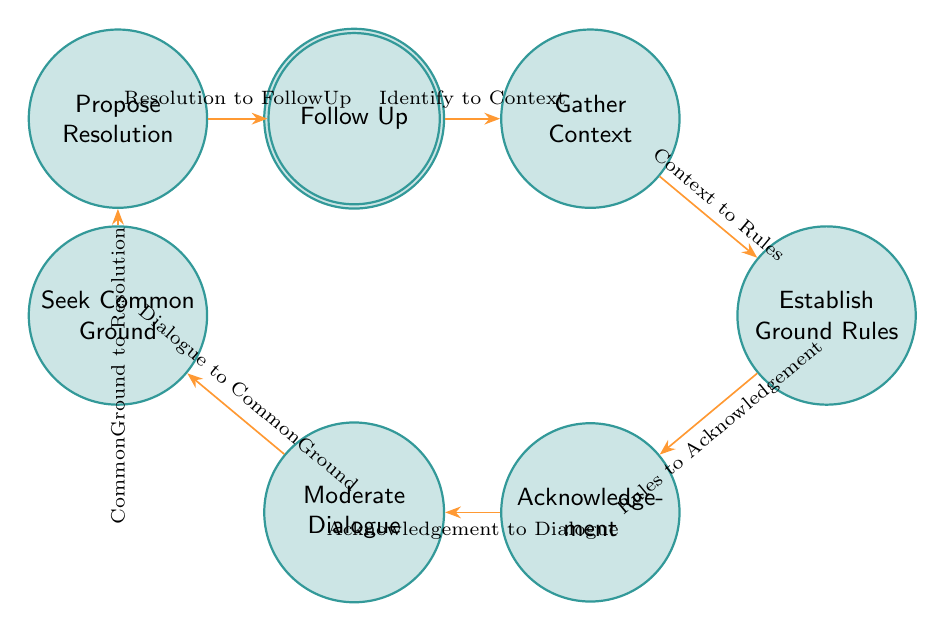What is the first state in the diagram? The first state listed in the diagram is "Identify Dispute," which is the starting point for addressing public disputes during forums.
Answer: Identify Dispute How many states are there in total? By counting each unique state in the state list, we find there are eight states represented: Identify Dispute, Gather Context, Establish Ground Rules, Acknowledgement, Moderate Dialogue, Seek Common Ground, Propose Resolution, and Follow Up.
Answer: Eight What is the transition from "Gather Context"? The transition from "Gather Context" leads to "Establish Ground Rules", as indicated in the transitions section.
Answer: Establish Ground Rules Which state follows "Propose Resolution"? The state that follows "Propose Resolution" is "Follow Up", as specified in the diagram's sequence of states.
Answer: Follow Up What is the relationship between "Moderate Dialogue" and "Seek Common Ground"? The relationship is that "Moderate Dialogue" transitions to "Seek Common Ground," indicating that after moderating dialogue, one seeks to identify commonalities between differing viewpoints.
Answer: Transition How many edges connect the states? By examining the transitions listed, there are seven edges connecting the eight states, indicating the flow of the process outlined.
Answer: Seven What is the purpose of "Establish Ground Rules"? "Establish Ground Rules" aims to set clear guidelines that govern how the discussion will be conducted, ensuring respectful and constructive dialogue among participants.
Answer: Set clear ground rules What precedes the "Moderate Dialogue" state? The state that precedes "Moderate Dialogue" is "Acknowledgement," indicating that parties' concerns and perspectives need to be acknowledged before facilitating the dialogue.
Answer: Acknowledgement What type of flow structure does this diagram represent? The diagram represents a finite state machine structure, which models the process of resolving public disputes through defined states and transitions between them.
Answer: Finite state machine 